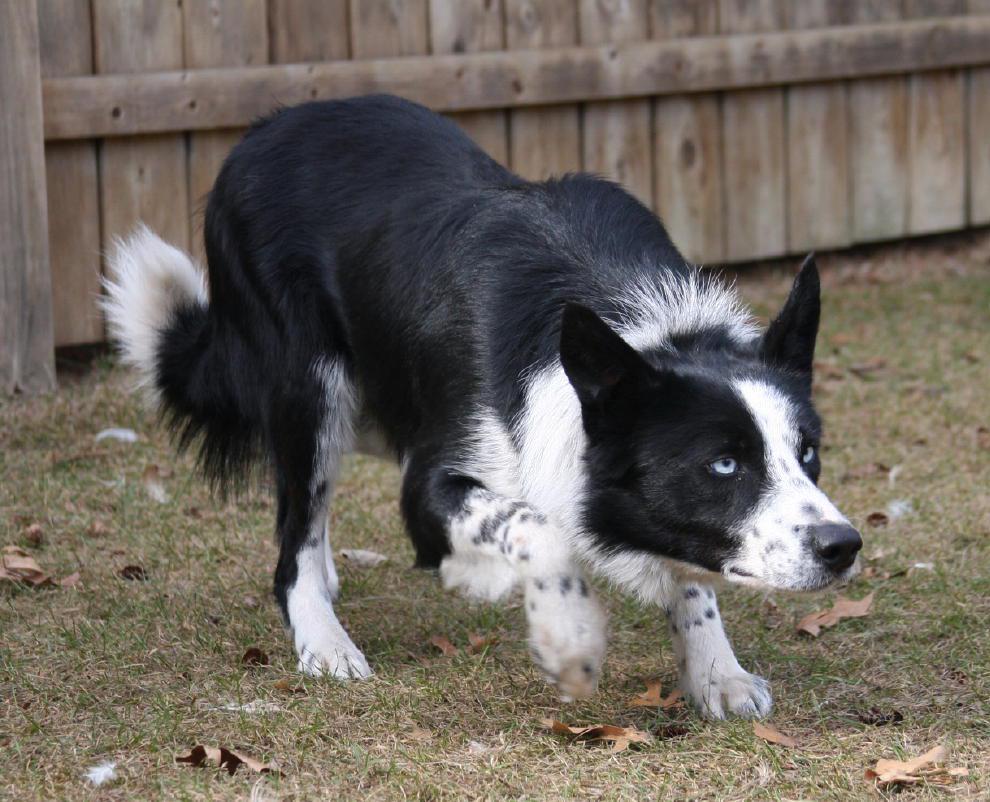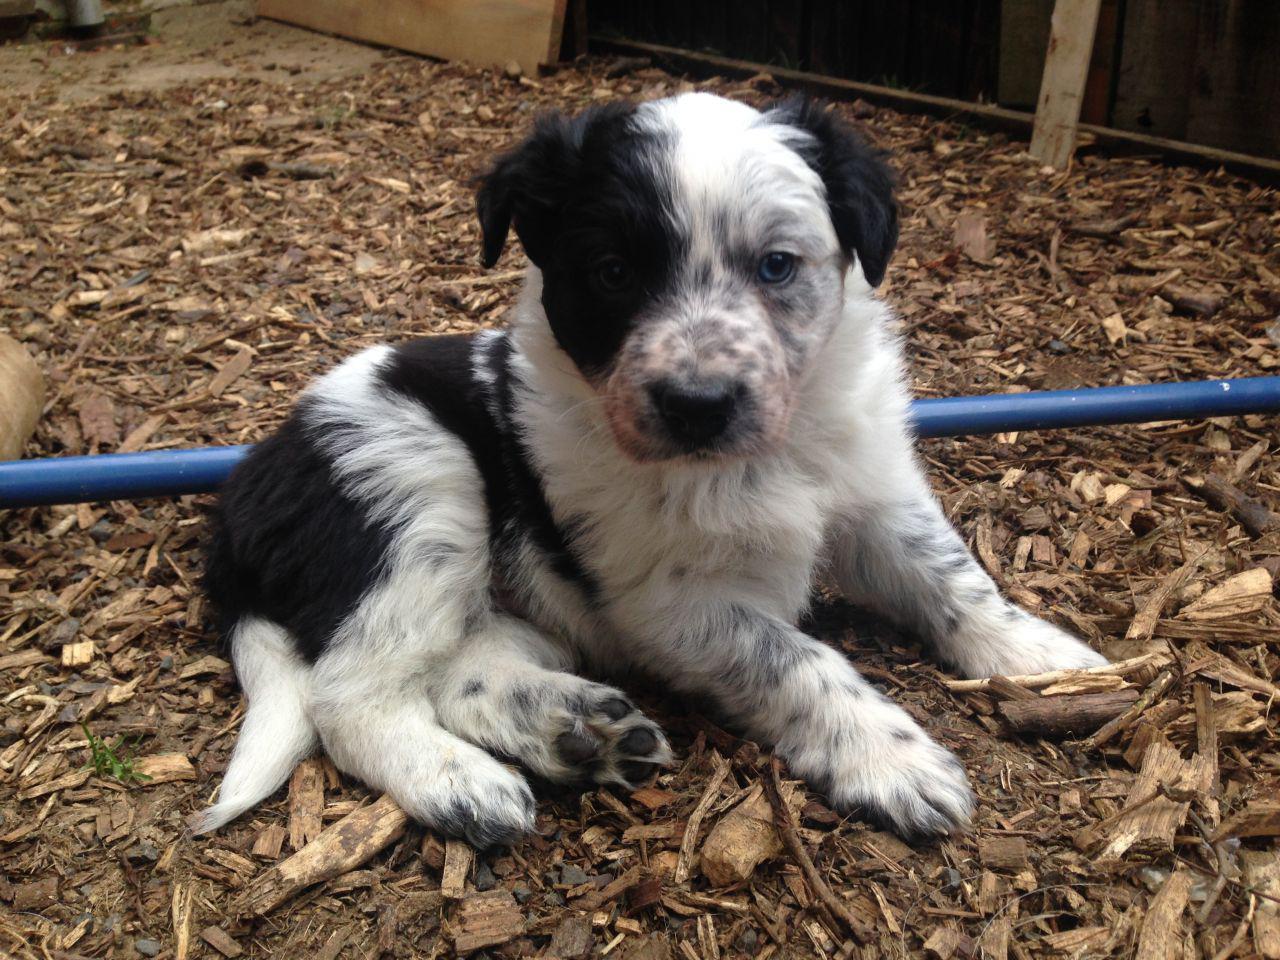The first image is the image on the left, the second image is the image on the right. Considering the images on both sides, is "A dog has its mouth open and showing its tongue." valid? Answer yes or no. No. The first image is the image on the left, the second image is the image on the right. Examine the images to the left and right. Is the description "One image shows a spotted puppy in a non-standing position, with both front paws extended." accurate? Answer yes or no. Yes. 